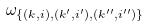<formula> <loc_0><loc_0><loc_500><loc_500>\omega _ { \{ ( k , i ) , ( k ^ { \prime } , i ^ { \prime } ) , ( k ^ { \prime \prime } , i ^ { \prime \prime } ) \} }</formula> 